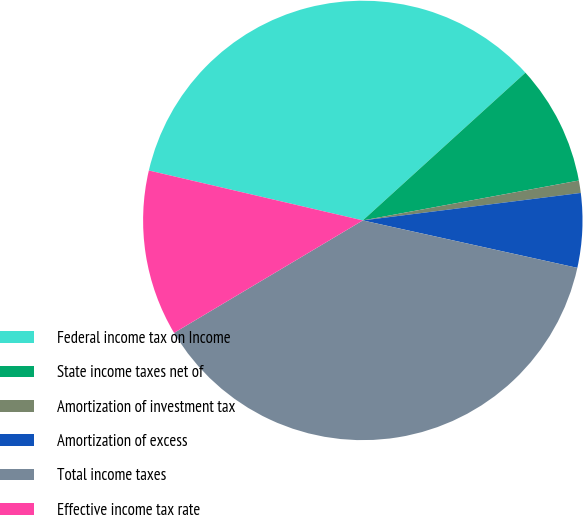Convert chart to OTSL. <chart><loc_0><loc_0><loc_500><loc_500><pie_chart><fcel>Federal income tax on Income<fcel>State income taxes net of<fcel>Amortization of investment tax<fcel>Amortization of excess<fcel>Total income taxes<fcel>Effective income tax rate<nl><fcel>34.61%<fcel>8.83%<fcel>0.91%<fcel>5.46%<fcel>37.98%<fcel>12.2%<nl></chart> 